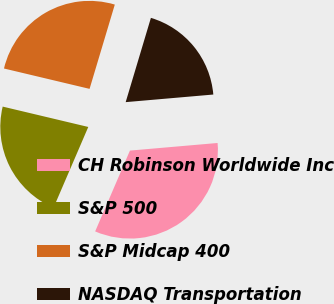Convert chart to OTSL. <chart><loc_0><loc_0><loc_500><loc_500><pie_chart><fcel>CH Robinson Worldwide Inc<fcel>S&P 500<fcel>S&P Midcap 400<fcel>NASDAQ Transportation<nl><fcel>32.84%<fcel>22.25%<fcel>25.91%<fcel>18.99%<nl></chart> 